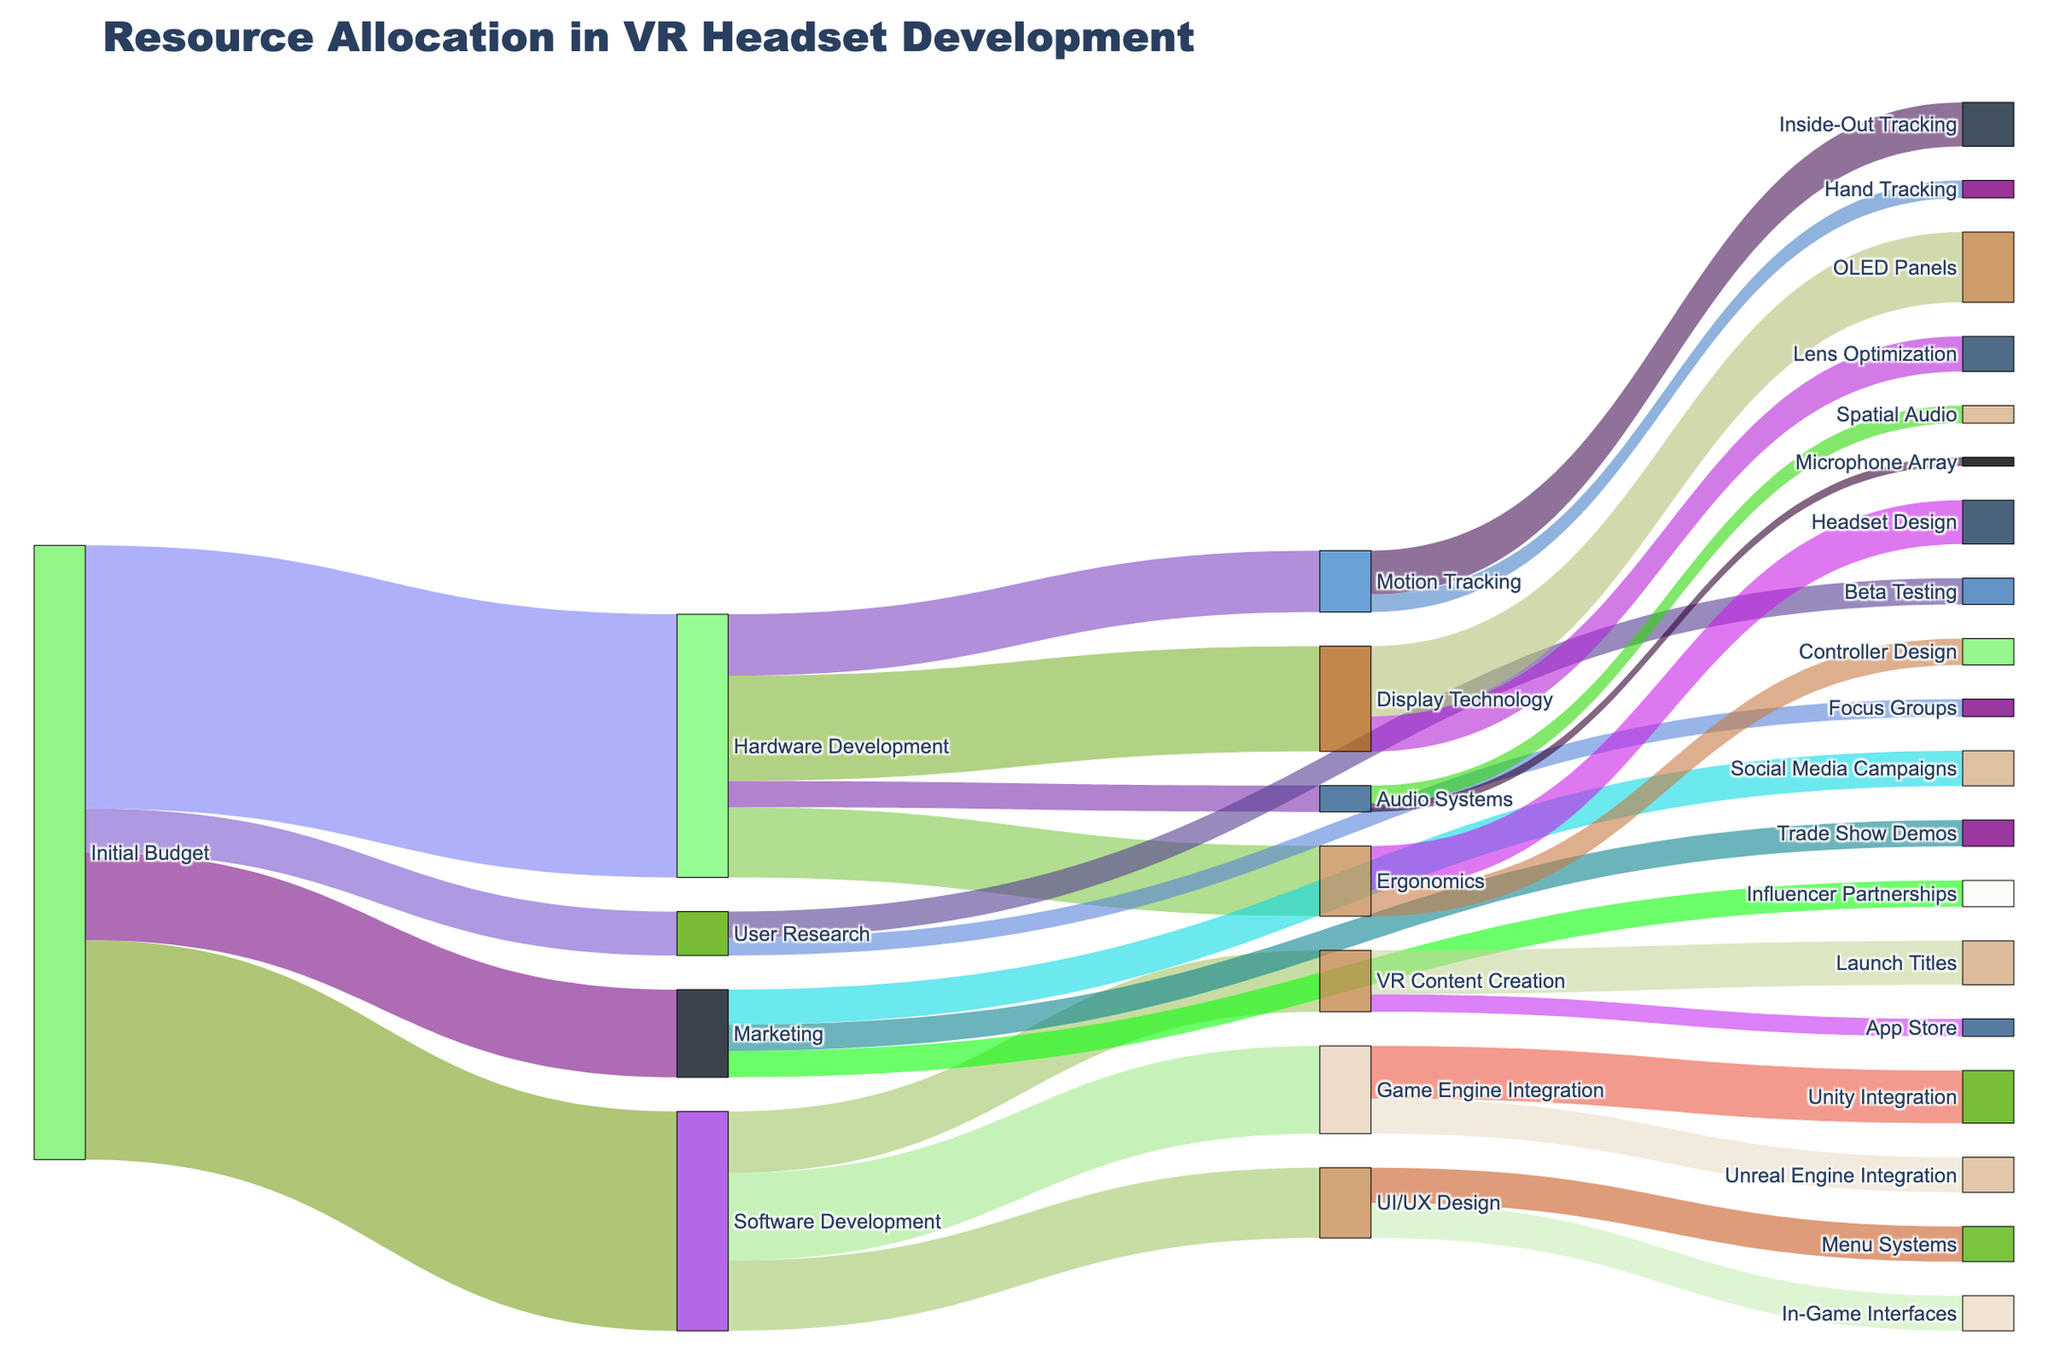What's the total initial budget allocated to user research? Look for the flow coming from 'Initial Budget' and going to 'User Research'. The value for this is directly indicated as the allocation amount.
Answer: 500000 Which hardware development sub-category received the most funding? Observe the flows coming out from 'Hardware Development'. Compare the values for 'Display Technology', 'Ergonomics', 'Motion Tracking', and 'Audio Systems'. 'Display Technology' has the highest value, 1200000.
Answer: Display Technology How much total budget was allocated from 'Initial Budget' to 'Hardware Development' and 'Software Development'? Sum the values of the budget flows from 'Initial Budget' to 'Hardware Development' and 'Software Development'. These are 3000000 and 2500000 respectively. Adding them gives 3000000 + 2500000 = 5500000.
Answer: 5500000 What percentage of the initial budget was allocated to marketing? Find the value of the flow from 'Initial Budget' to 'Marketing' and divide it by the total initial budget. The value for marketing is 1000000, and the initial budget is 7000000. So, (1000000 / 7000000) * 100 = 14.29%.
Answer: 14.29% Compare the budget allocation for 'Game Engine Integration' and 'UI/UX Design' under 'Software Development'. Which received more? Analyze the flows from 'Software Development' to 'Game Engine Integration' and 'UI/UX Design'. The values are 1000000 for 'Game Engine Integration' and 800000 for 'UI/UX Design'. 'Game Engine Integration' received more.
Answer: Game Engine Integration What's the smallest allocation under 'Marketing' and how much is it? Look into the sub-categories under 'Marketing' and identify the smallest flow. Compare 'Social Media Campaigns', 'Influencer Partnerships', and 'Trade Show Demos'. The smallest value is 'Influencer Partnerships' with 300000.
Answer: Influencer Partnerships, 300000 How much funding was directed towards 'Motion Tracking' and how was it divided further? Identify the total value flowing into 'Motion Tracking' from 'Hardware Development', which is 700000, then split into 'Inside-Out Tracking' and 'Hand Tracking'. 'Inside-Out Tracking' gets 500000 and 'Hand Tracking' gets 200000.
Answer: 700000; Inside-Out Tracking: 500000, Hand Tracking: 200000 What is the overall amount allocated specifically for 'Inside-Out Tracking' and 'Unreal Engine Integration'? Find the values for 'Inside-Out Tracking' and 'Unreal Engine Integration' individually and sum them up. They are 500000 and 400000 respectively, giving a total of 500000 + 400000 = 900000.
Answer: 900000 What is the combined total allocation for 'Focus Groups' and 'Beta Testing' within 'User Research'? Sum the values allocated to 'Focus Groups' and 'Beta Testing'. They are 200000 and 300000 respectively. So, 200000 + 300000 = 500000.
Answer: 500000 